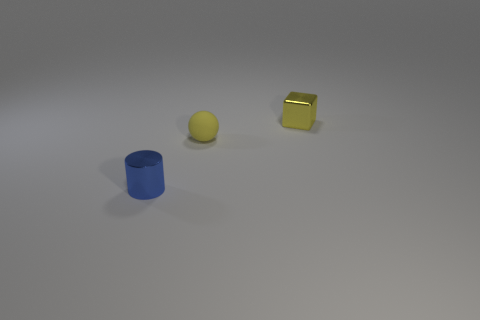What number of tiny objects are either blue metallic cylinders or yellow objects?
Your answer should be very brief. 3. Is there any other thing that has the same color as the ball?
Your response must be concise. Yes. What material is the small yellow object that is in front of the tiny metallic thing that is behind the object in front of the sphere?
Offer a terse response. Rubber. Is there any other thing that has the same material as the tiny sphere?
Offer a very short reply. No. How many small metal things are in front of the yellow rubber sphere and to the right of the tiny blue cylinder?
Give a very brief answer. 0. There is a small metallic object that is on the right side of the small thing that is on the left side of the tiny yellow matte sphere; what color is it?
Offer a terse response. Yellow. Is the number of small cylinders that are behind the yellow metallic object the same as the number of tiny yellow balls?
Your answer should be very brief. No. How many small metal objects are behind the tiny metallic object that is left of the small object that is behind the small ball?
Your answer should be very brief. 1. There is a thing behind the small matte sphere; what is its color?
Offer a very short reply. Yellow. There is a tiny metallic object that is behind the blue shiny thing; what number of objects are in front of it?
Provide a short and direct response. 2. 